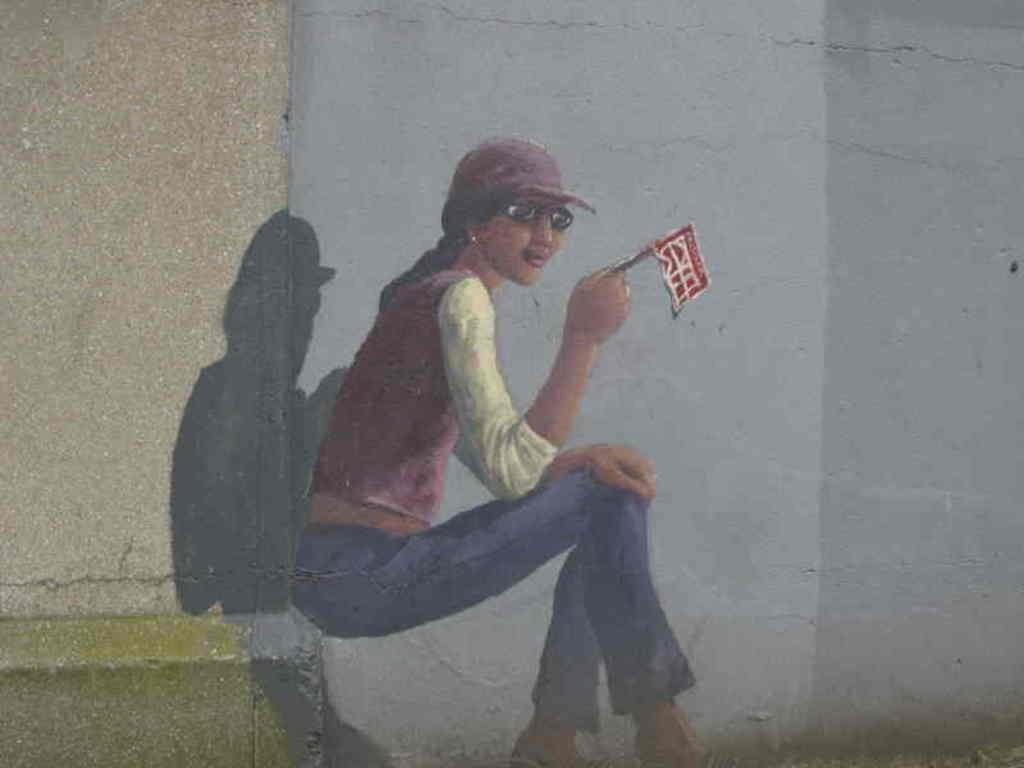What is on the wall in the image? There is a painting on the wall in the image. What is the woman in the image doing? The woman is seated in the image. What is the woman holding in the image? The woman is holding a flag in the image. What type of eyewear is the woman wearing in the image? The woman is wearing sunglasses in the image. What is on the woman's head in the image? The woman is wearing a cap on her head in the image. What type of chalk is the woman using to write on the hall floor in the image? There is no chalk or hall floor present in the image; it features a painting on the wall, a seated woman holding a flag, and the woman wearing sunglasses and a cap. 